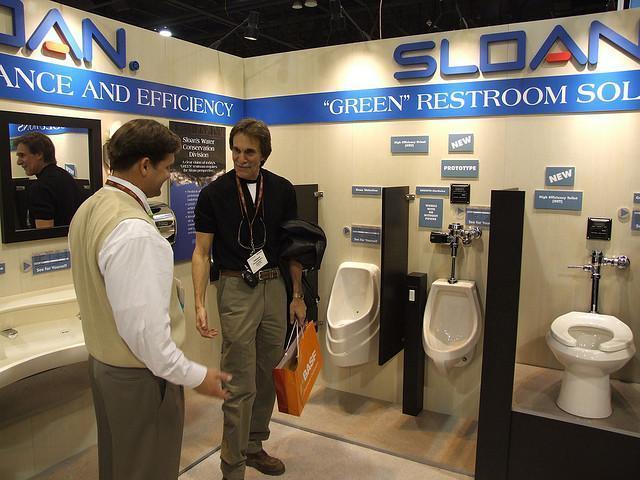How many men are present?
Give a very brief answer. 2. How many toilets are in view?
Give a very brief answer. 1. How many toilets are there?
Give a very brief answer. 3. How many people are in the picture?
Give a very brief answer. 2. 